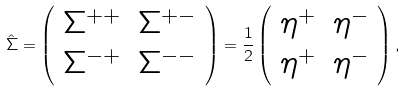Convert formula to latex. <formula><loc_0><loc_0><loc_500><loc_500>\hat { \Sigma } = \left ( \begin{array} { c c } \Sigma ^ { + + } & \Sigma ^ { + - } \\ \Sigma ^ { - + } & \Sigma ^ { - - } \end{array} \right ) = \frac { 1 } { 2 } \left ( \begin{array} { c c } \eta ^ { + } & \eta ^ { - } \\ \eta ^ { + } & \eta ^ { - } \end{array} \right ) ,</formula> 